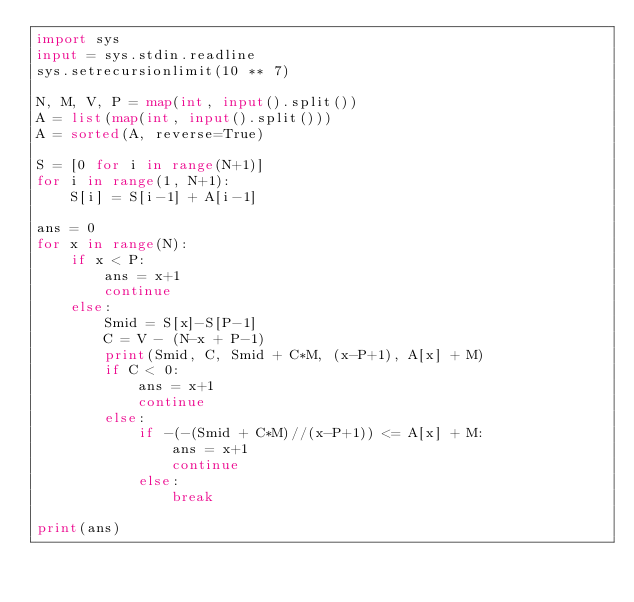<code> <loc_0><loc_0><loc_500><loc_500><_Python_>import sys
input = sys.stdin.readline
sys.setrecursionlimit(10 ** 7)

N, M, V, P = map(int, input().split())
A = list(map(int, input().split()))
A = sorted(A, reverse=True)

S = [0 for i in range(N+1)]
for i in range(1, N+1):
    S[i] = S[i-1] + A[i-1]

ans = 0
for x in range(N):
    if x < P:
        ans = x+1
        continue
    else:
        Smid = S[x]-S[P-1]
        C = V - (N-x + P-1)
        print(Smid, C, Smid + C*M, (x-P+1), A[x] + M)
        if C < 0:
            ans = x+1
            continue
        else:
            if -(-(Smid + C*M)//(x-P+1)) <= A[x] + M:
                ans = x+1
                continue
            else:
                break

print(ans)

        
</code> 